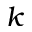<formula> <loc_0><loc_0><loc_500><loc_500>k</formula> 